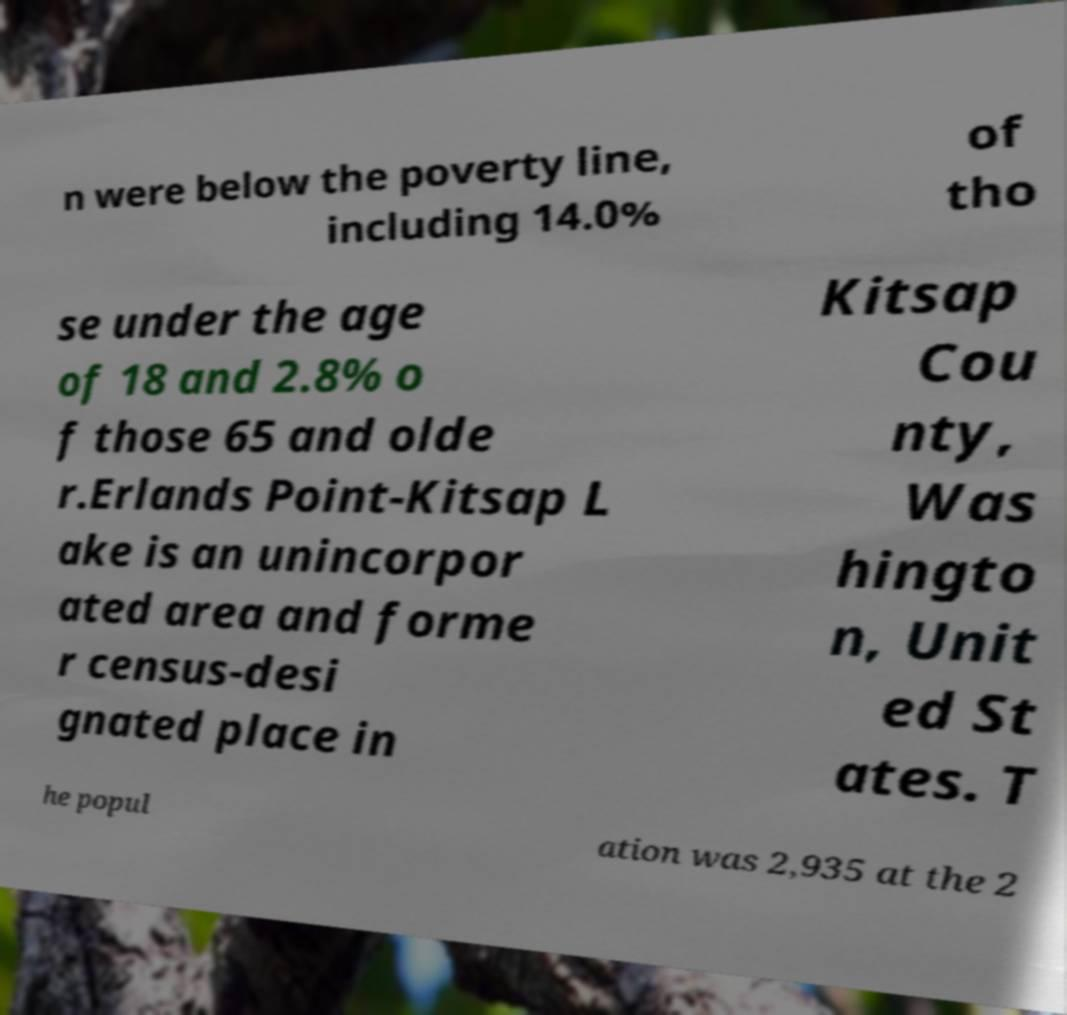What messages or text are displayed in this image? I need them in a readable, typed format. n were below the poverty line, including 14.0% of tho se under the age of 18 and 2.8% o f those 65 and olde r.Erlands Point-Kitsap L ake is an unincorpor ated area and forme r census-desi gnated place in Kitsap Cou nty, Was hingto n, Unit ed St ates. T he popul ation was 2,935 at the 2 